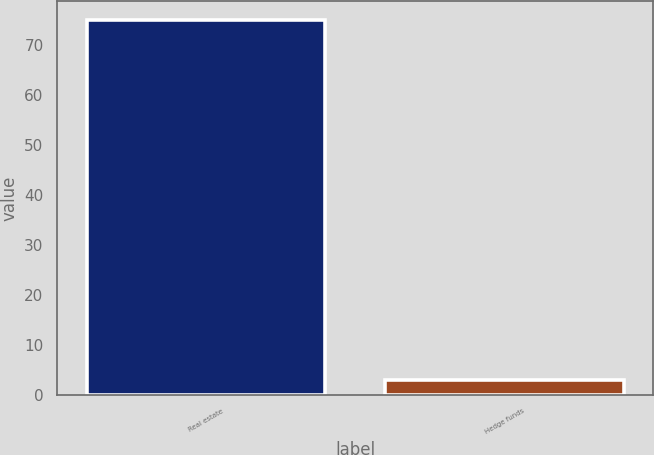Convert chart to OTSL. <chart><loc_0><loc_0><loc_500><loc_500><bar_chart><fcel>Real estate<fcel>Hedge funds<nl><fcel>75<fcel>3<nl></chart> 